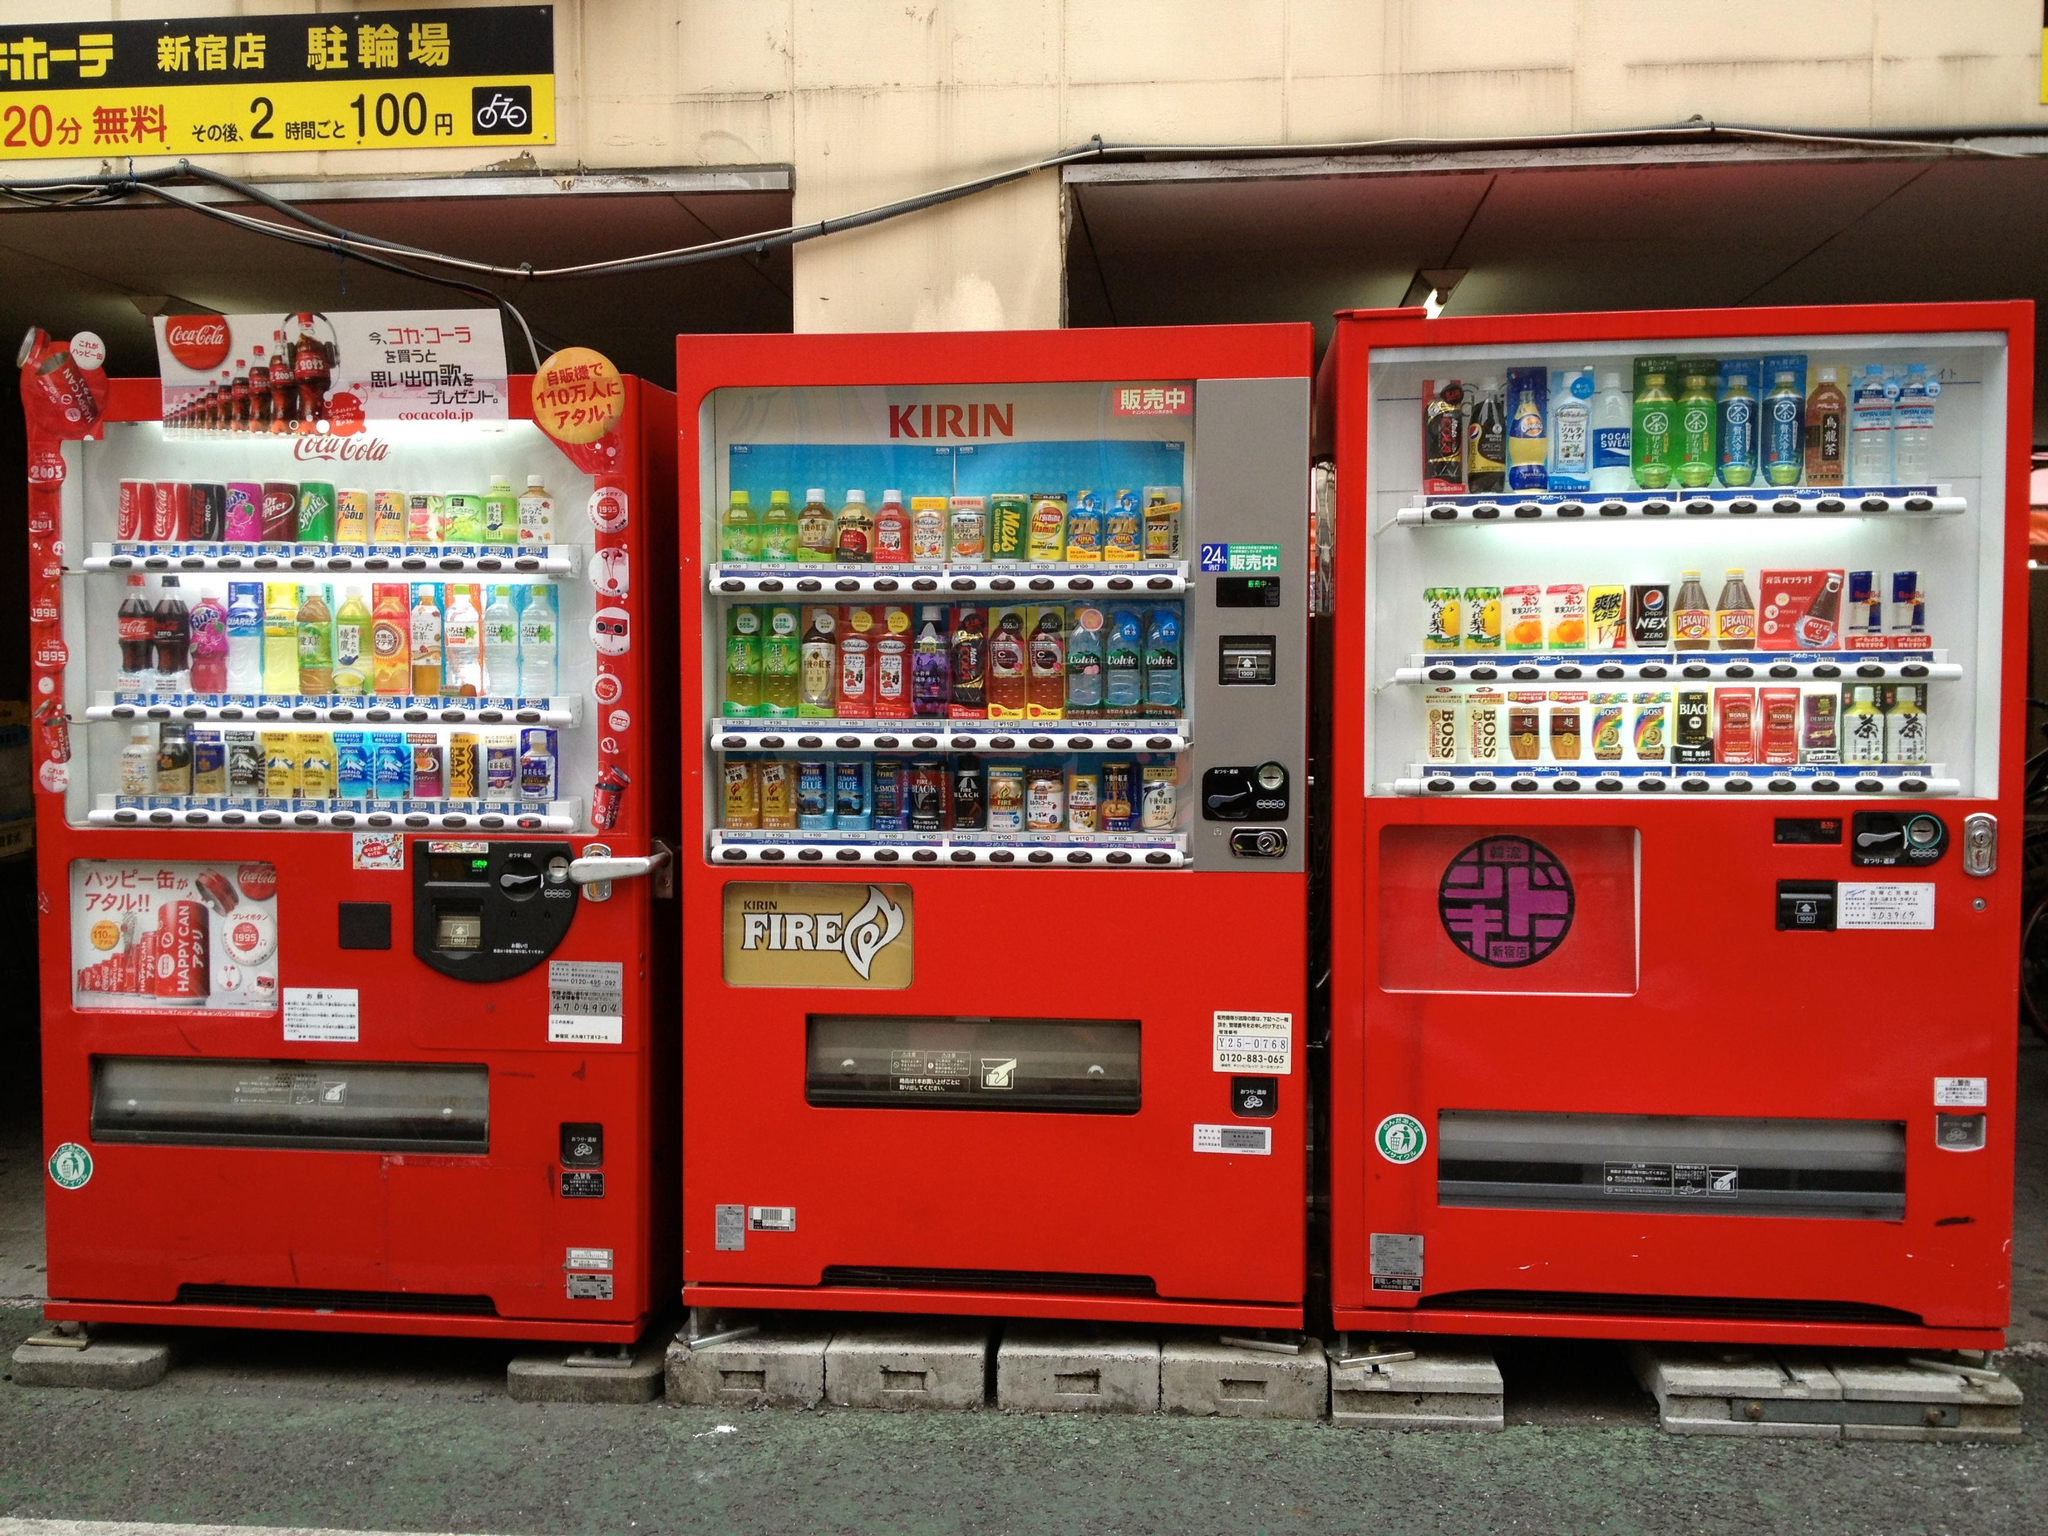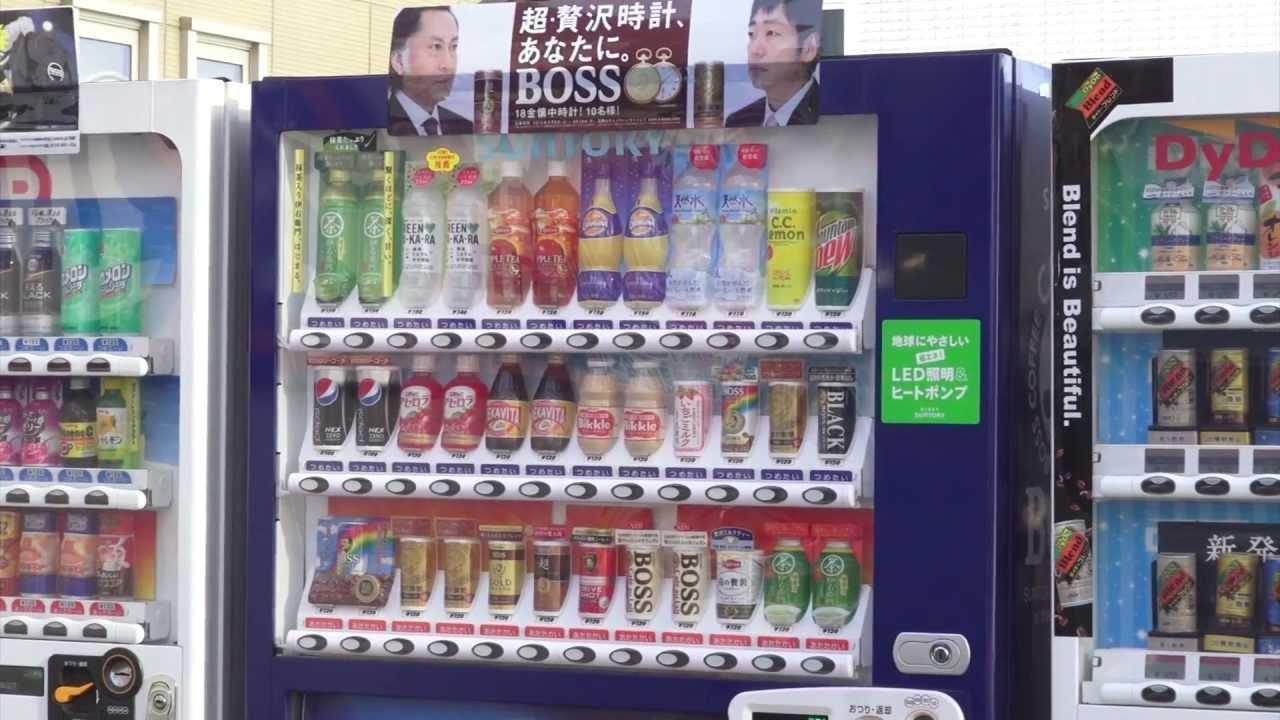The first image is the image on the left, the second image is the image on the right. Assess this claim about the two images: "there is a person in one of the iamges.". Correct or not? Answer yes or no. No. The first image is the image on the left, the second image is the image on the right. Examine the images to the left and right. Is the description "A dark-haired young man in a suit jacket is in the right of one image." accurate? Answer yes or no. No. 